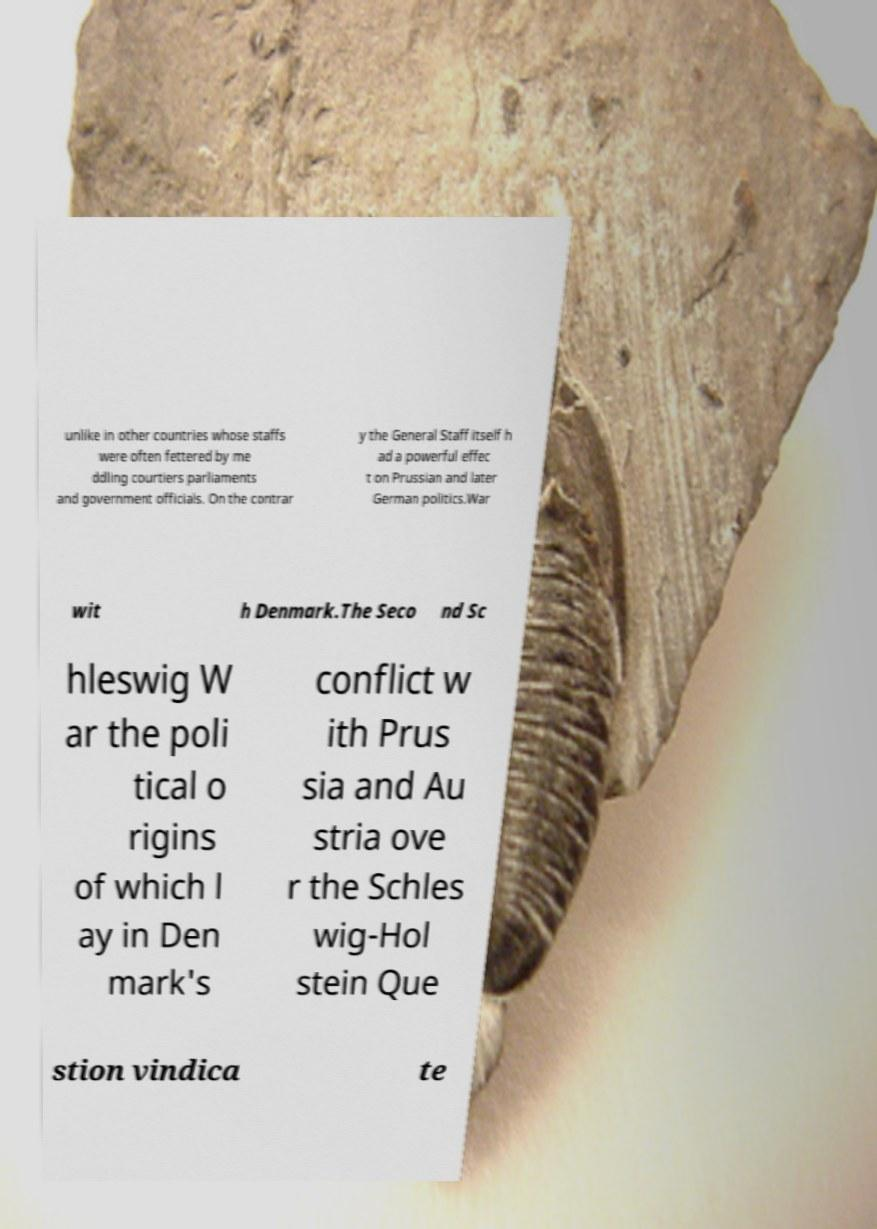Please read and relay the text visible in this image. What does it say? unlike in other countries whose staffs were often fettered by me ddling courtiers parliaments and government officials. On the contrar y the General Staff itself h ad a powerful effec t on Prussian and later German politics.War wit h Denmark.The Seco nd Sc hleswig W ar the poli tical o rigins of which l ay in Den mark's conflict w ith Prus sia and Au stria ove r the Schles wig-Hol stein Que stion vindica te 